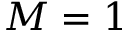<formula> <loc_0><loc_0><loc_500><loc_500>M = 1</formula> 